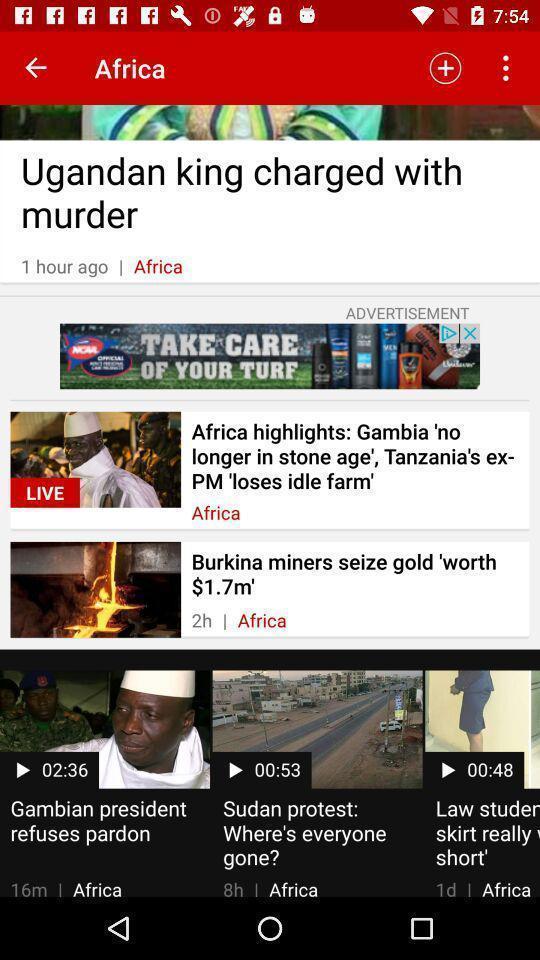Tell me about the visual elements in this screen capture. Screen shows different news in a news app. 